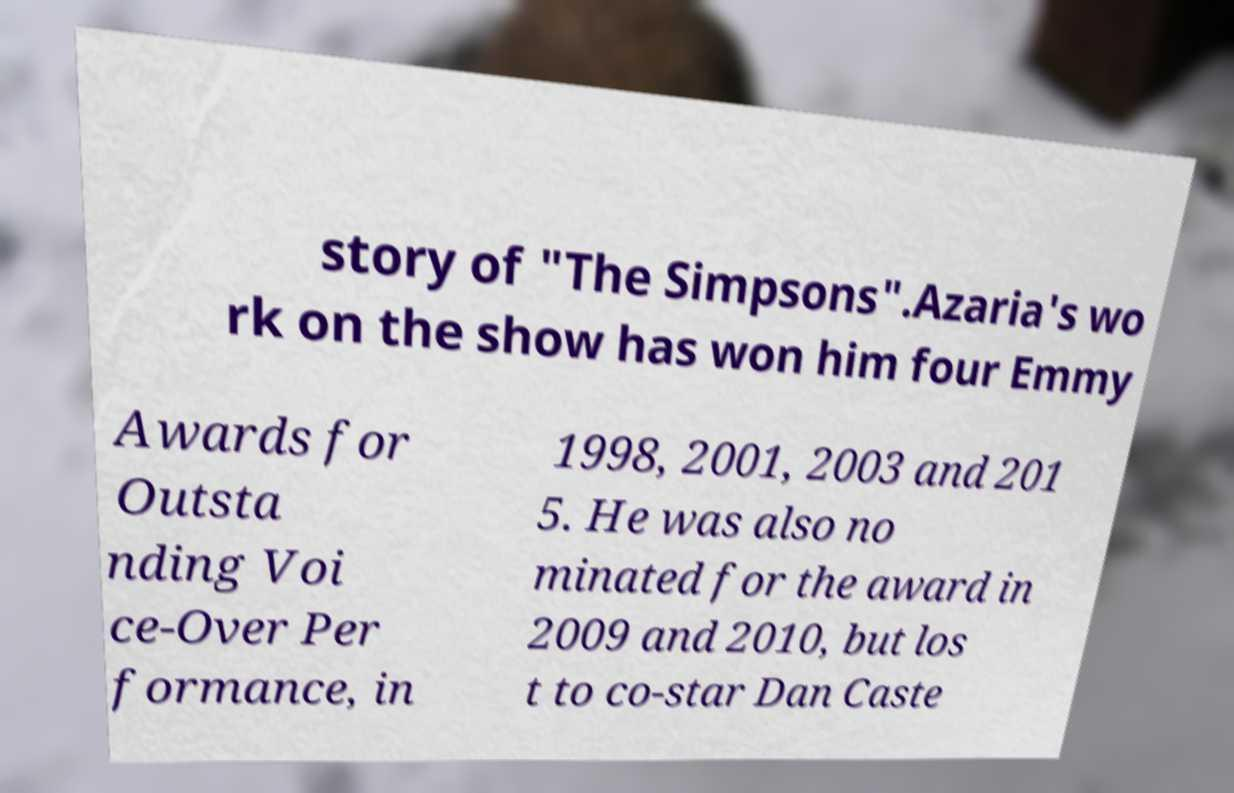Can you read and provide the text displayed in the image?This photo seems to have some interesting text. Can you extract and type it out for me? story of "The Simpsons".Azaria's wo rk on the show has won him four Emmy Awards for Outsta nding Voi ce-Over Per formance, in 1998, 2001, 2003 and 201 5. He was also no minated for the award in 2009 and 2010, but los t to co-star Dan Caste 